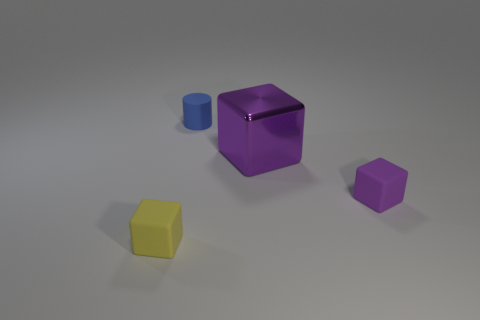Subtract all small purple cubes. How many cubes are left? 2 Add 2 large purple cubes. How many objects exist? 6 Subtract all purple blocks. How many blocks are left? 1 Subtract all brown balls. How many purple cubes are left? 2 Subtract all yellow matte blocks. Subtract all large objects. How many objects are left? 2 Add 1 small blue rubber objects. How many small blue rubber objects are left? 2 Add 2 rubber objects. How many rubber objects exist? 5 Subtract 0 brown cylinders. How many objects are left? 4 Subtract all cubes. How many objects are left? 1 Subtract 1 cubes. How many cubes are left? 2 